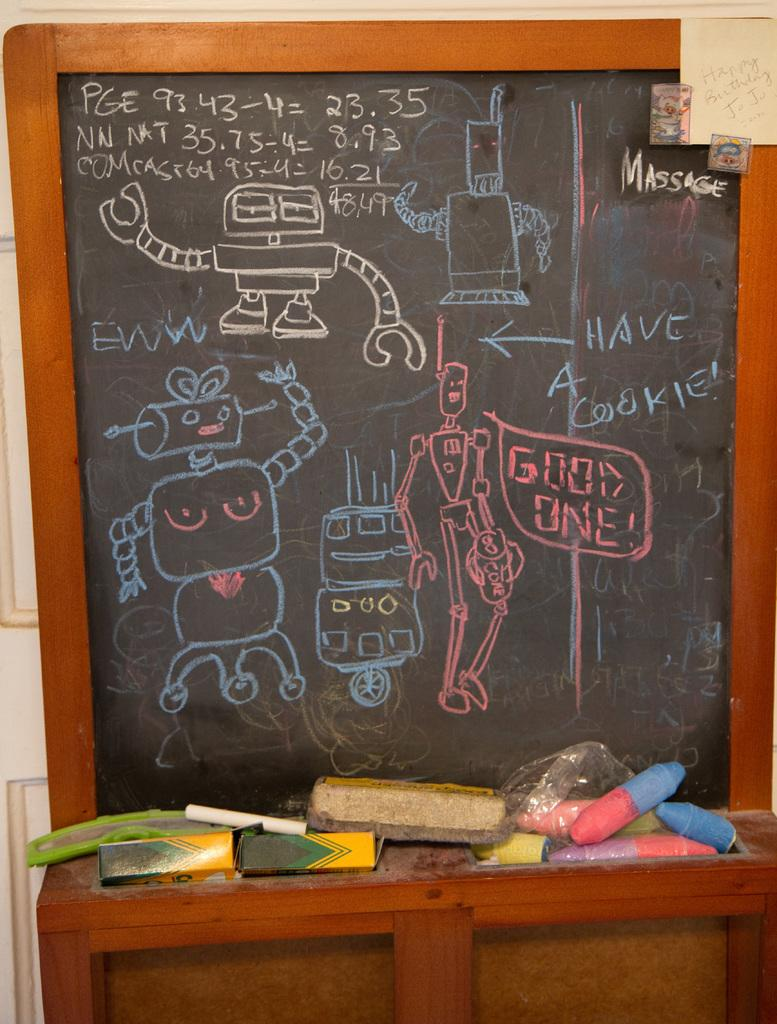<image>
Give a short and clear explanation of the subsequent image. A chalk board full of robot drawings portrays a robot saying "Good One!". 